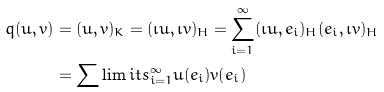<formula> <loc_0><loc_0><loc_500><loc_500>q ( u , v ) & = ( u , v ) _ { K } = ( \iota u , \iota v ) _ { H } = \sum _ { i = 1 } ^ { \infty } ( \iota u , e _ { i } ) _ { H } ( e _ { i } , \iota v ) _ { H } \\ & = \sum \lim i t s _ { i = 1 } ^ { \infty } u ( e _ { i } ) v ( e _ { i } )</formula> 